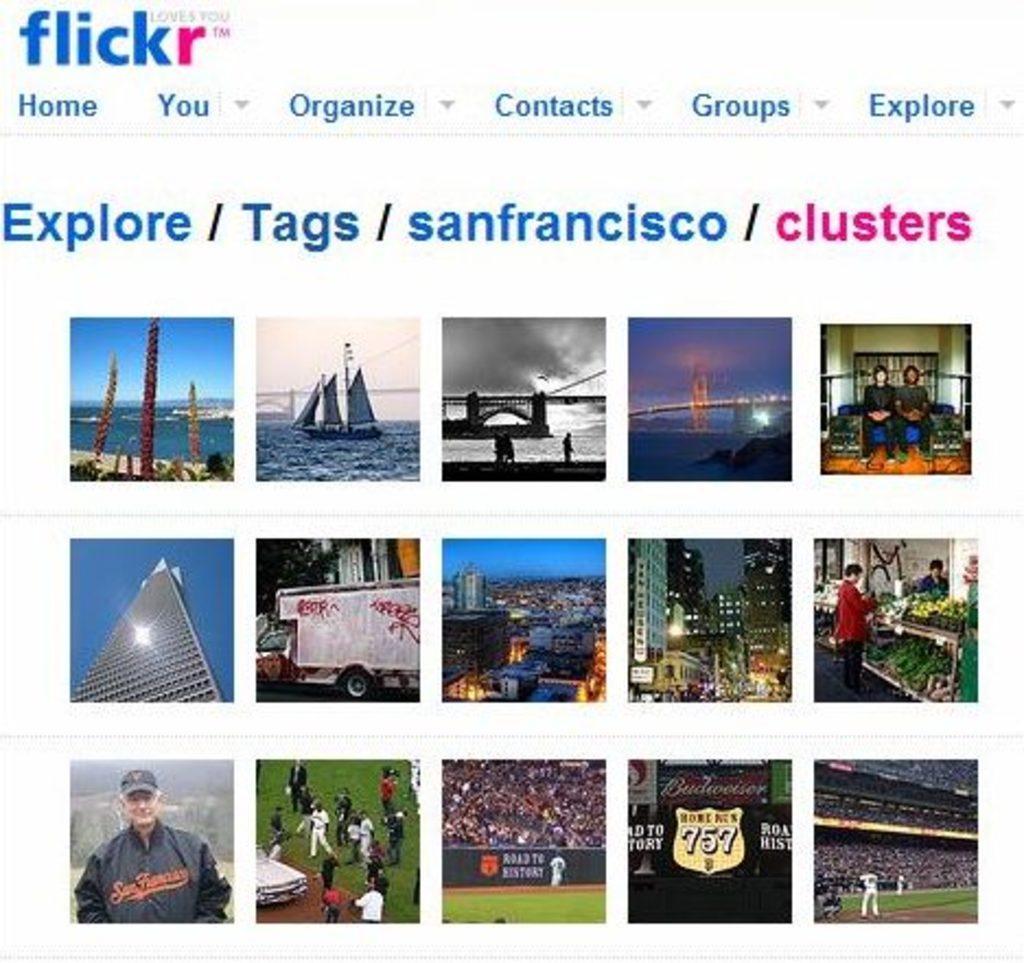Can you describe this image briefly? In the image I can see one website page. In the image I can see water, bridge, people, building, and playground. At the top of the image I can see some written text. 